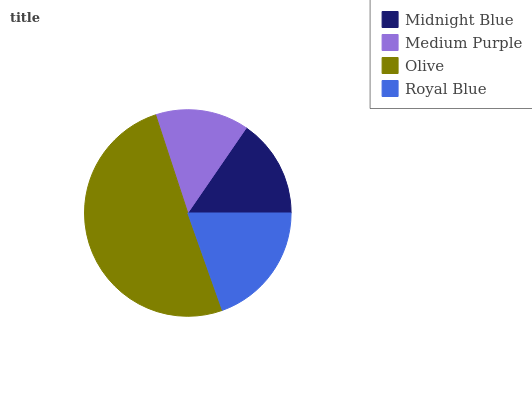Is Medium Purple the minimum?
Answer yes or no. Yes. Is Olive the maximum?
Answer yes or no. Yes. Is Olive the minimum?
Answer yes or no. No. Is Medium Purple the maximum?
Answer yes or no. No. Is Olive greater than Medium Purple?
Answer yes or no. Yes. Is Medium Purple less than Olive?
Answer yes or no. Yes. Is Medium Purple greater than Olive?
Answer yes or no. No. Is Olive less than Medium Purple?
Answer yes or no. No. Is Royal Blue the high median?
Answer yes or no. Yes. Is Midnight Blue the low median?
Answer yes or no. Yes. Is Midnight Blue the high median?
Answer yes or no. No. Is Olive the low median?
Answer yes or no. No. 